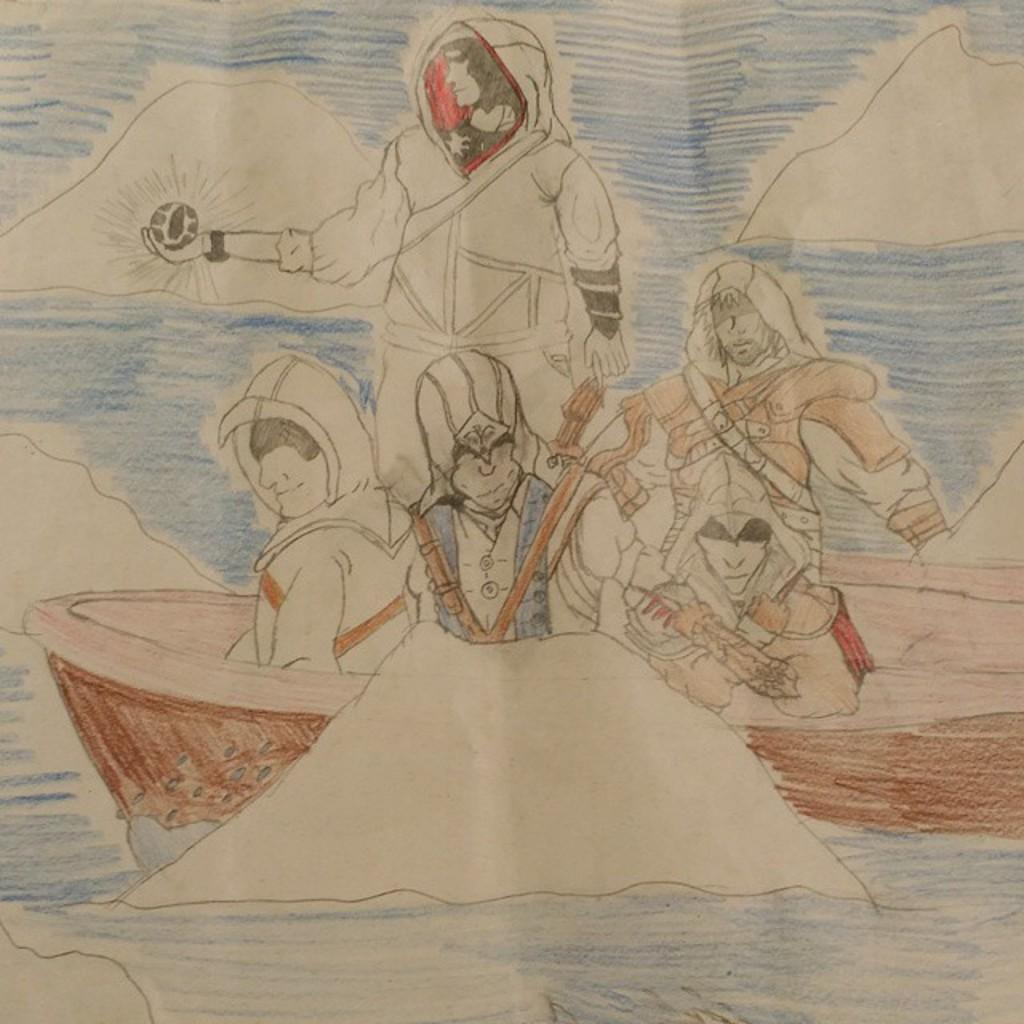What type of art is depicted in the image? The image is a drawing art. Can you describe the subjects in the image? There are people in the image. What other object can be seen in the image besides the people? There is a boat-like object in the image. What type of door can be seen in the image? There is no door present in the image; it is a drawing art featuring people and a boat-like object. 